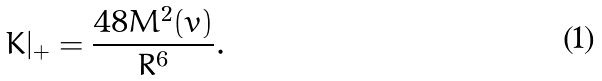<formula> <loc_0><loc_0><loc_500><loc_500>K | _ { + } = \frac { 4 8 M ^ { 2 } ( v ) } { R ^ { 6 } } .</formula> 